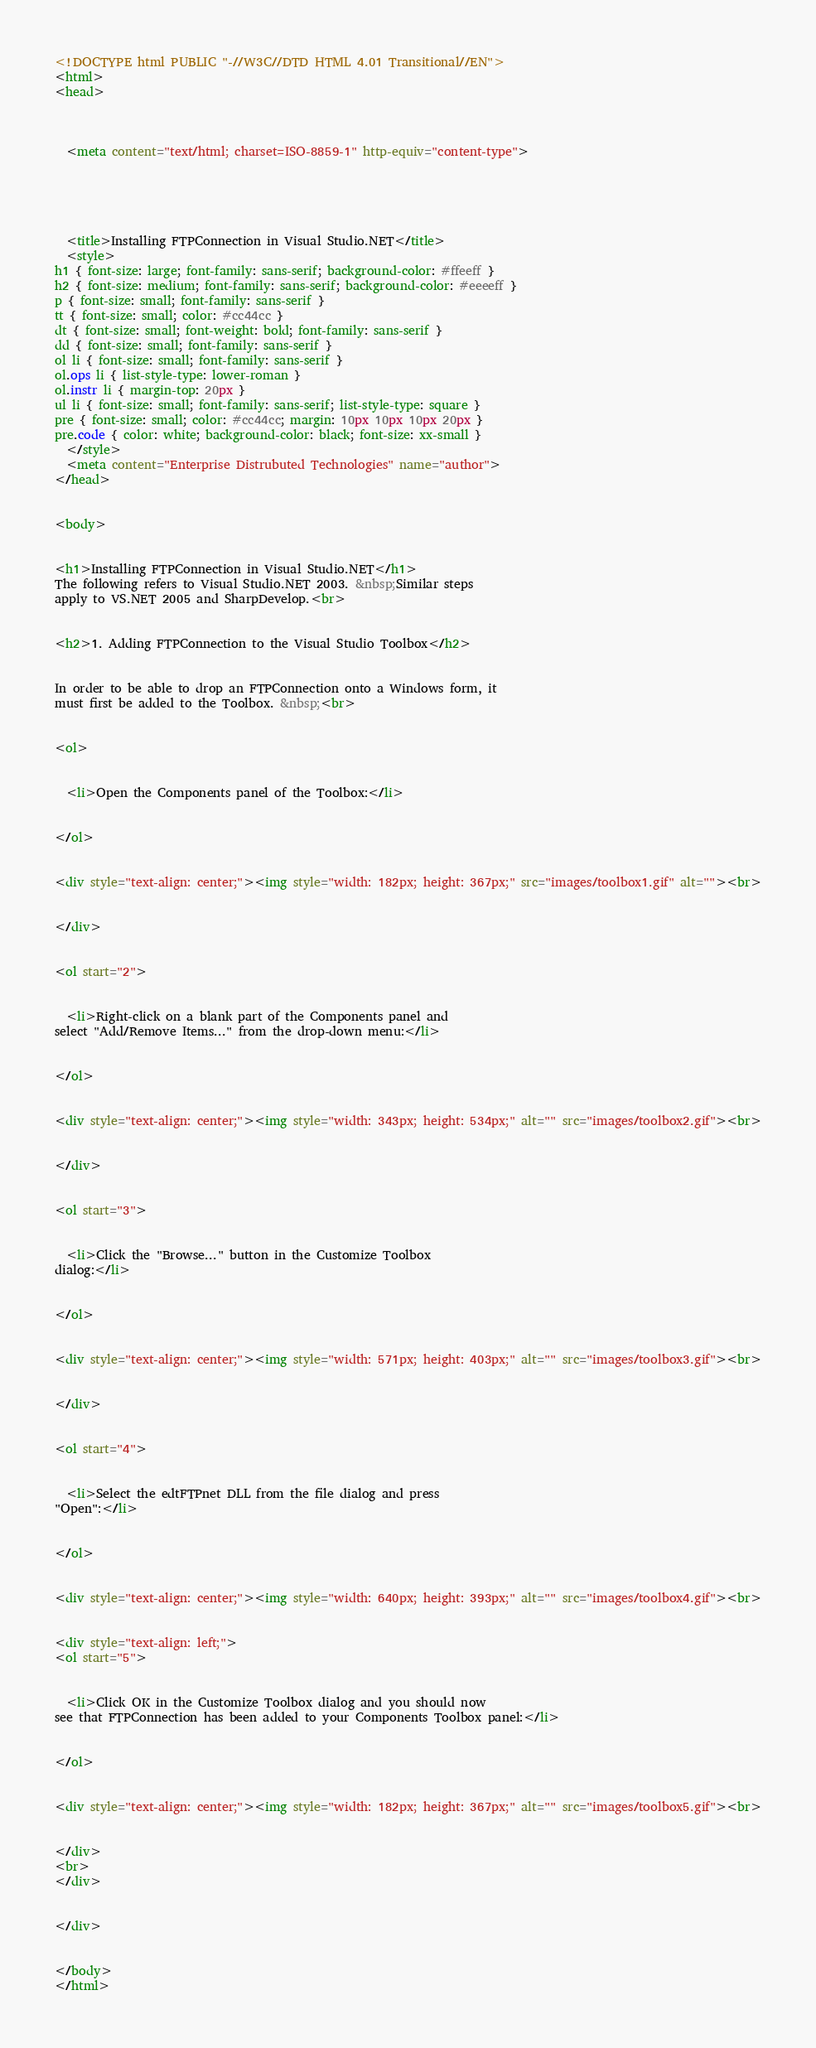Convert code to text. <code><loc_0><loc_0><loc_500><loc_500><_HTML_><!DOCTYPE html PUBLIC "-//W3C//DTD HTML 4.01 Transitional//EN">
<html>
<head>


  
  <meta content="text/html; charset=ISO-8859-1" http-equiv="content-type">

  


  
  <title>Installing FTPConnection in Visual Studio.NET</title>
  <style>
h1 { font-size: large; font-family: sans-serif; background-color: #ffeeff }
h2 { font-size: medium; font-family: sans-serif; background-color: #eeeeff }
p { font-size: small; font-family: sans-serif }
tt { font-size: small; color: #cc44cc }
dt { font-size: small; font-weight: bold; font-family: sans-serif }
dd { font-size: small; font-family: sans-serif }
ol li { font-size: small; font-family: sans-serif }
ol.ops li { list-style-type: lower-roman }
ol.instr li { margin-top: 20px }
ul li { font-size: small; font-family: sans-serif; list-style-type: square }
pre { font-size: small; color: #cc44cc; margin: 10px 10px 10px 20px }
pre.code { color: white; background-color: black; font-size: xx-small }
  </style>
  <meta content="Enterprise Distrubuted Technologies" name="author">
</head>


<body>


<h1>Installing FTPConnection in Visual Studio.NET</h1>
The following refers to Visual Studio.NET 2003. &nbsp;Similar steps
apply to VS.NET 2005 and SharpDevelop.<br>


<h2>1. Adding FTPConnection to the Visual Studio Toolbox</h2>


In order to be able to drop an FTPConnection onto a Windows form, it
must first be added to the Toolbox. &nbsp;<br>


<ol>


  <li>Open the Components panel of the Toolbox:</li>


</ol>


<div style="text-align: center;"><img style="width: 182px; height: 367px;" src="images/toolbox1.gif" alt=""><br>


</div>


<ol start="2">


  <li>Right-click on a blank part of the Components panel and
select "Add/Remove Items..." from the drop-down menu:</li>


</ol>


<div style="text-align: center;"><img style="width: 343px; height: 534px;" alt="" src="images/toolbox2.gif"><br>


</div>


<ol start="3">


  <li>Click the "Browse..." button in the Customize Toolbox
dialog:</li>


</ol>


<div style="text-align: center;"><img style="width: 571px; height: 403px;" alt="" src="images/toolbox3.gif"><br>


</div>


<ol start="4">


  <li>Select the edtFTPnet DLL from the file dialog and press
"Open":</li>


</ol>


<div style="text-align: center;"><img style="width: 640px; height: 393px;" alt="" src="images/toolbox4.gif"><br>


<div style="text-align: left;">
<ol start="5">


  <li>Click OK in the Customize Toolbox dialog and you should now
see that FTPConnection has been added to your Components Toolbox panel:</li>


</ol>


<div style="text-align: center;"><img style="width: 182px; height: 367px;" alt="" src="images/toolbox5.gif"><br>


</div>
<br>
</div>


</div>


</body>
</html>
</code> 